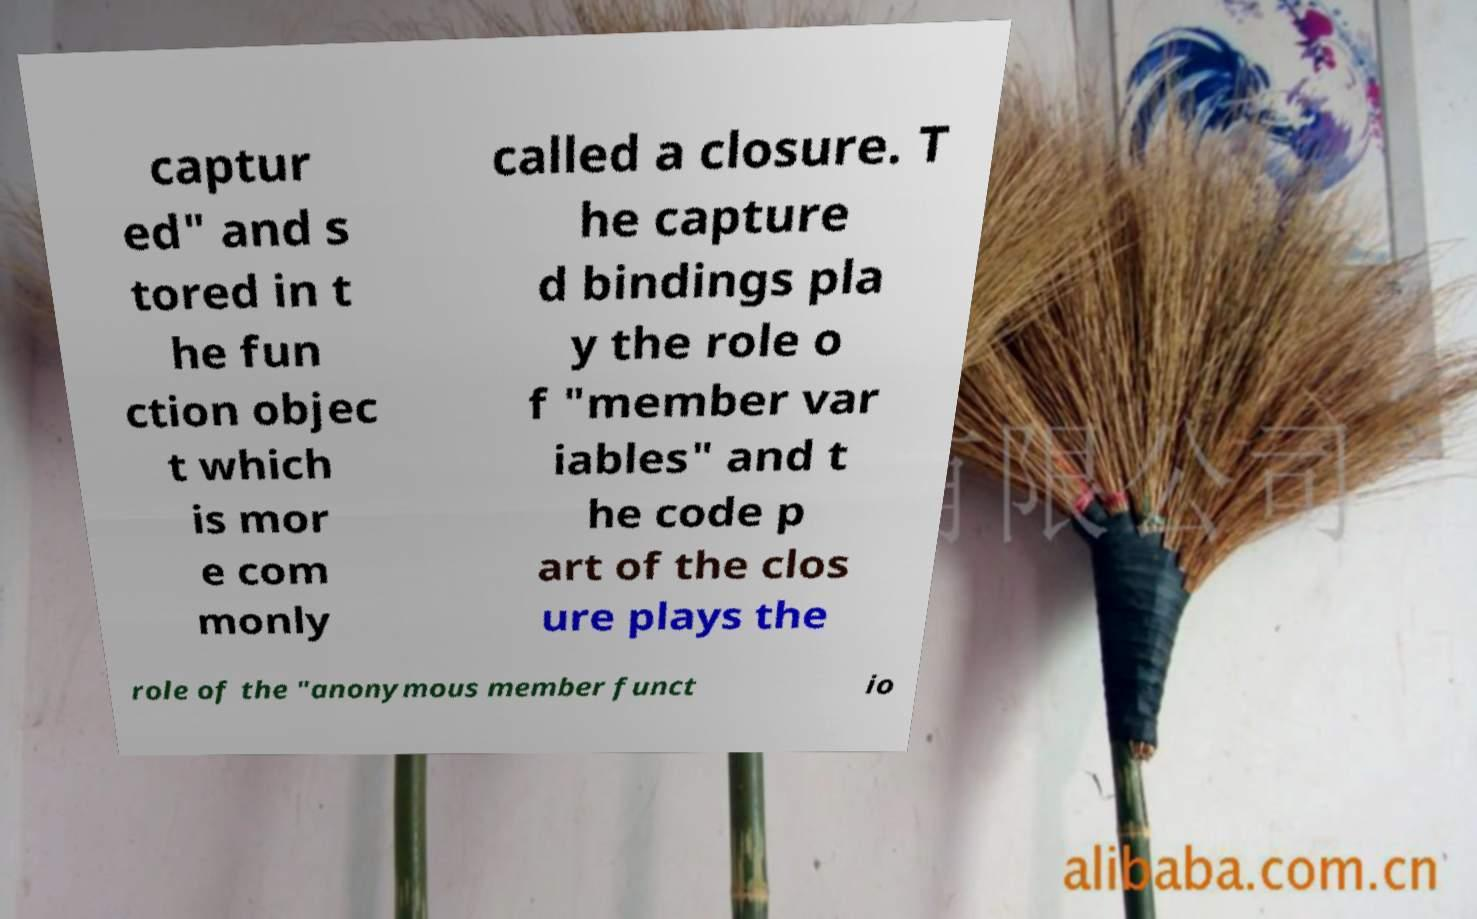I need the written content from this picture converted into text. Can you do that? captur ed" and s tored in t he fun ction objec t which is mor e com monly called a closure. T he capture d bindings pla y the role o f "member var iables" and t he code p art of the clos ure plays the role of the "anonymous member funct io 